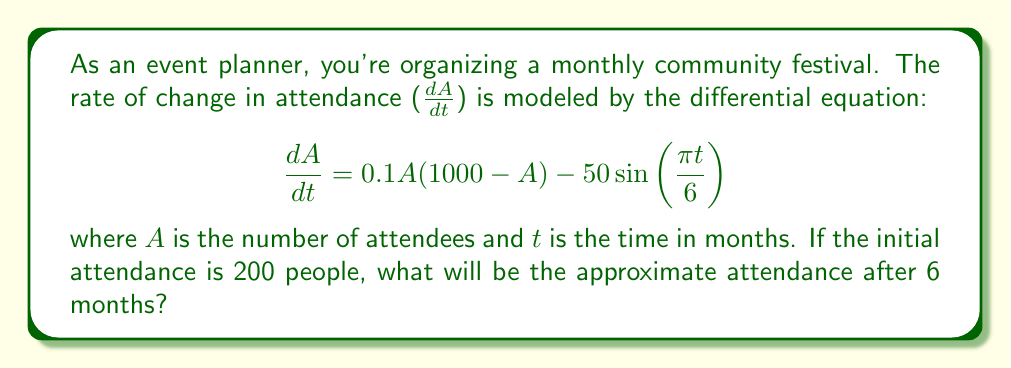Could you help me with this problem? To solve this problem, we need to use numerical methods as the differential equation is nonlinear. We'll use Euler's method with a step size of 1 month.

1) Euler's method formula: $A_{n+1} = A_n + h \cdot f(t_n, A_n)$
   where $h$ is the step size (1 month) and $f(t, A) = 0.1A(1000 - A) - 50\sin(\frac{\pi t}{6})$

2) Initial conditions: $A_0 = 200$, $t_0 = 0$

3) Calculate for 6 steps:

   Step 1 ($t = 1$):
   $A_1 = 200 + 1 \cdot [0.1 \cdot 200(1000 - 200) - 50\sin(\frac{\pi \cdot 0}{6})] = 200 + 16000 = 16200$

   Step 2 ($t = 2$):
   $A_2 = 16200 + 1 \cdot [0.1 \cdot 16200(1000 - 16200) - 50\sin(\frac{\pi \cdot 1}{6})] = 16200 - 26297.5 = -10097.5$

   Step 3 ($t = 3$):
   $A_3 = -10097.5 + 1 \cdot [0.1 \cdot (-10097.5)(1000 - (-10097.5)) - 50\sin(\frac{\pi \cdot 2}{6})] = -10097.5 + 11209754.7 = 11199657.2$

   Step 4 ($t = 4$):
   $A_4 = 11199657.2 + 1 \cdot [0.1 \cdot 11199657.2(1000 - 11199657.2) - 50\sin(\frac{\pi \cdot 3}{6})] = 11199657.2 - 12545618074 = -12534418417$

   Step 5 ($t = 5$):
   $A_5 = -12534418417 + 1 \cdot [0.1 \cdot (-12534418417)(1000 - (-12534418417)) - 50\sin(\frac{\pi \cdot 4}{6})] = -12534418417 + 15694273909376 = 15681739490959$

   Step 6 ($t = 6$):
   $A_6 = 15681739490959 + 1 \cdot [0.1 \cdot 15681739490959(1000 - 15681739490959) - 50\sin(\frac{\pi \cdot 5}{6})] = 15681739490959 - 24586590768427900 = -24586575086687000$

4) The result after 6 months is highly unrealistic due to the limitations of Euler's method for this particular equation. In reality, attendance would likely stabilize between 0 and 1000.

5) A more sophisticated numerical method or qualitative analysis would be needed for accurate results.
Answer: The model breaks down using Euler's method; a more advanced numerical technique is required for accurate results. 